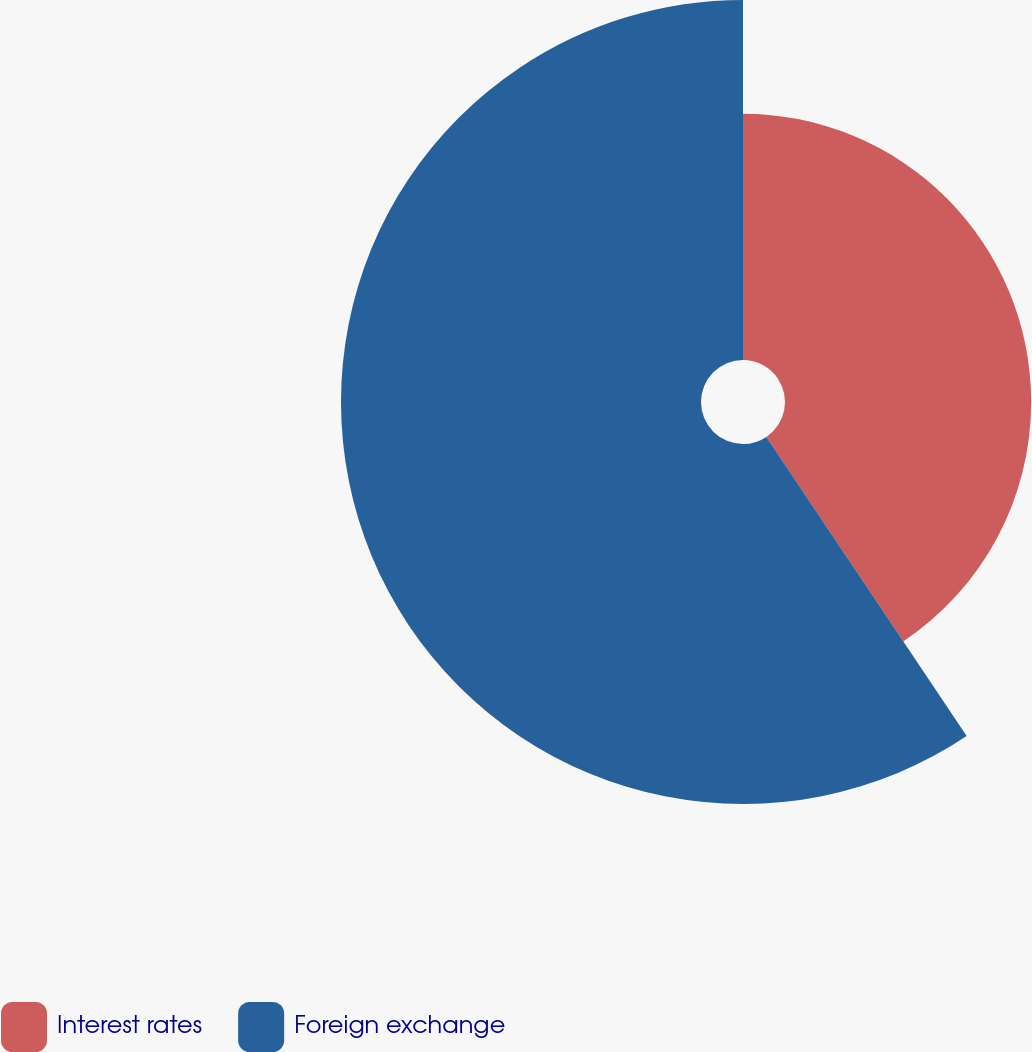Convert chart to OTSL. <chart><loc_0><loc_0><loc_500><loc_500><pie_chart><fcel>Interest rates<fcel>Foreign exchange<nl><fcel>40.61%<fcel>59.39%<nl></chart> 